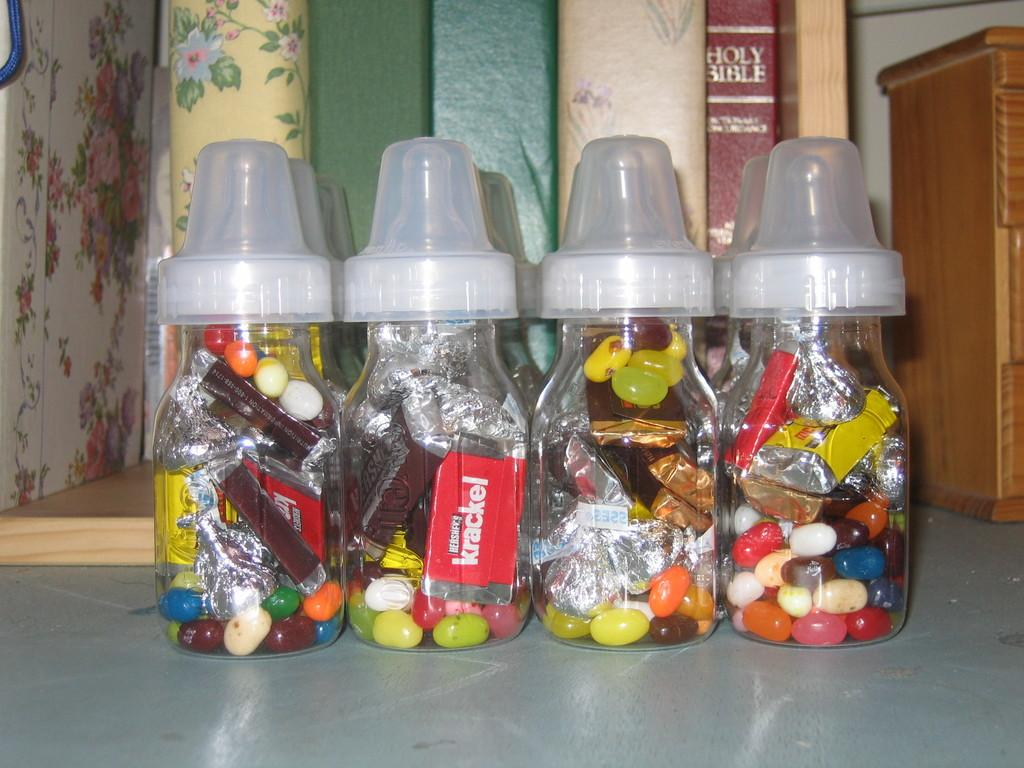How many bottles are visible in the image? There are four bottles in the image. What is written on the bottles? The bottles are labelled as 'KRACKEL'. Where are the bottles located in the image? The bottles are placed on the floor. What is on the right side of the image? There is a table on the right side of the image. What can be found on the table? There are books on the table. How many flowers are on the table in the image? There are no flowers visible in the image; only books are present on the table. 